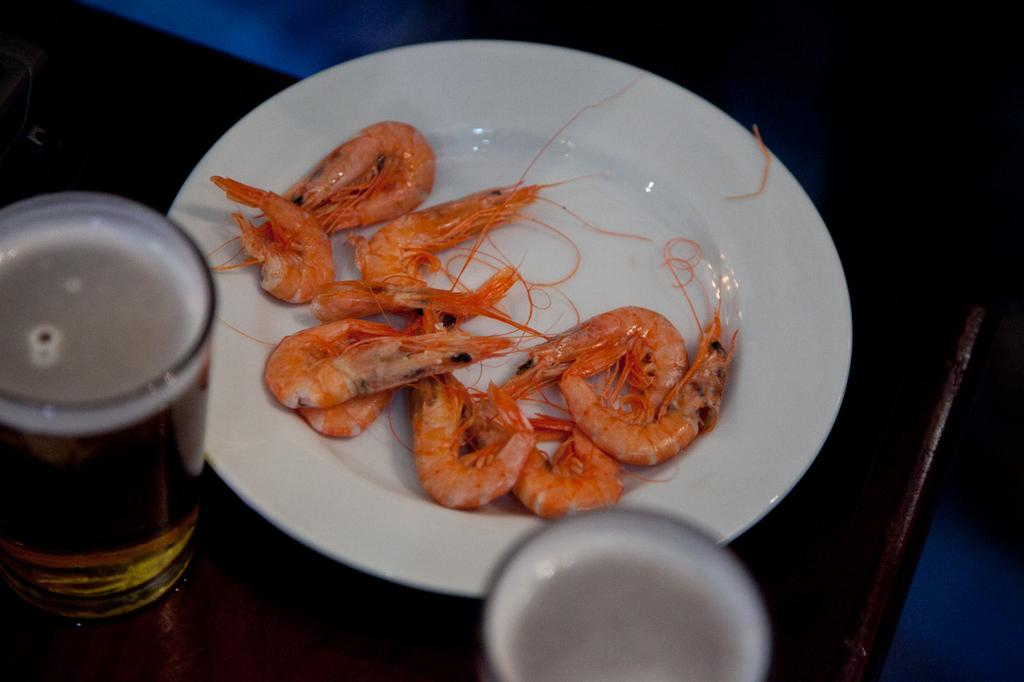What is the main food item visible on the plate in the image? Unfortunately, the specific food item cannot be determined from the provided facts. What can be found on the table besides the plate? There are glasses with liquids in them on the table. How would you describe the lighting in the image? The background of the image is dark. What type of caption is written on the food item in the image? There is no caption written on the food item in the image. Can you tell me how many quarters are visible in the image? There are no quarters present in the image. 